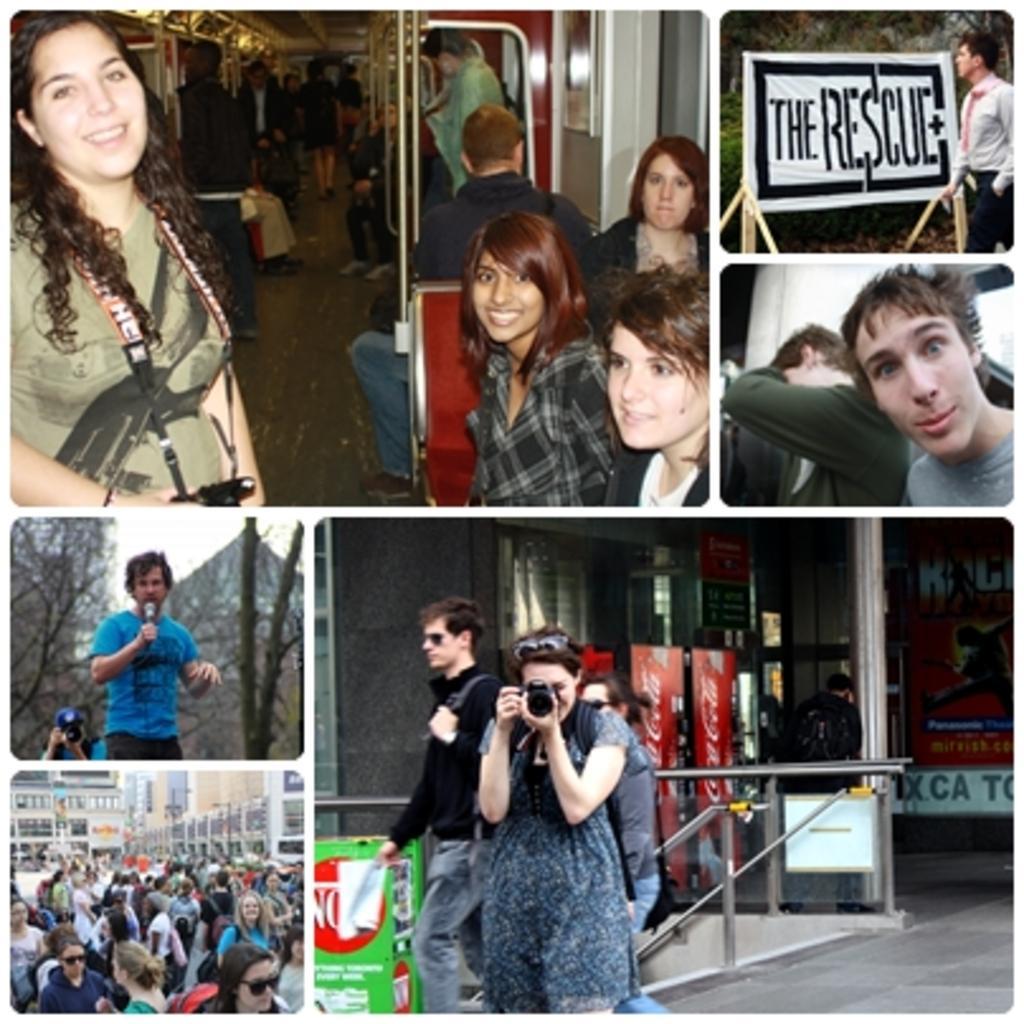How would you summarize this image in a sentence or two? The image is a collage of pictures. At the top the picture is taken in a train. On the right there is a hoarding and people. At the bottom towards right, in the picture there is a woman holding camera, behind her there are people walking. On the left there are crowd. In the center there is a person holding mic. 